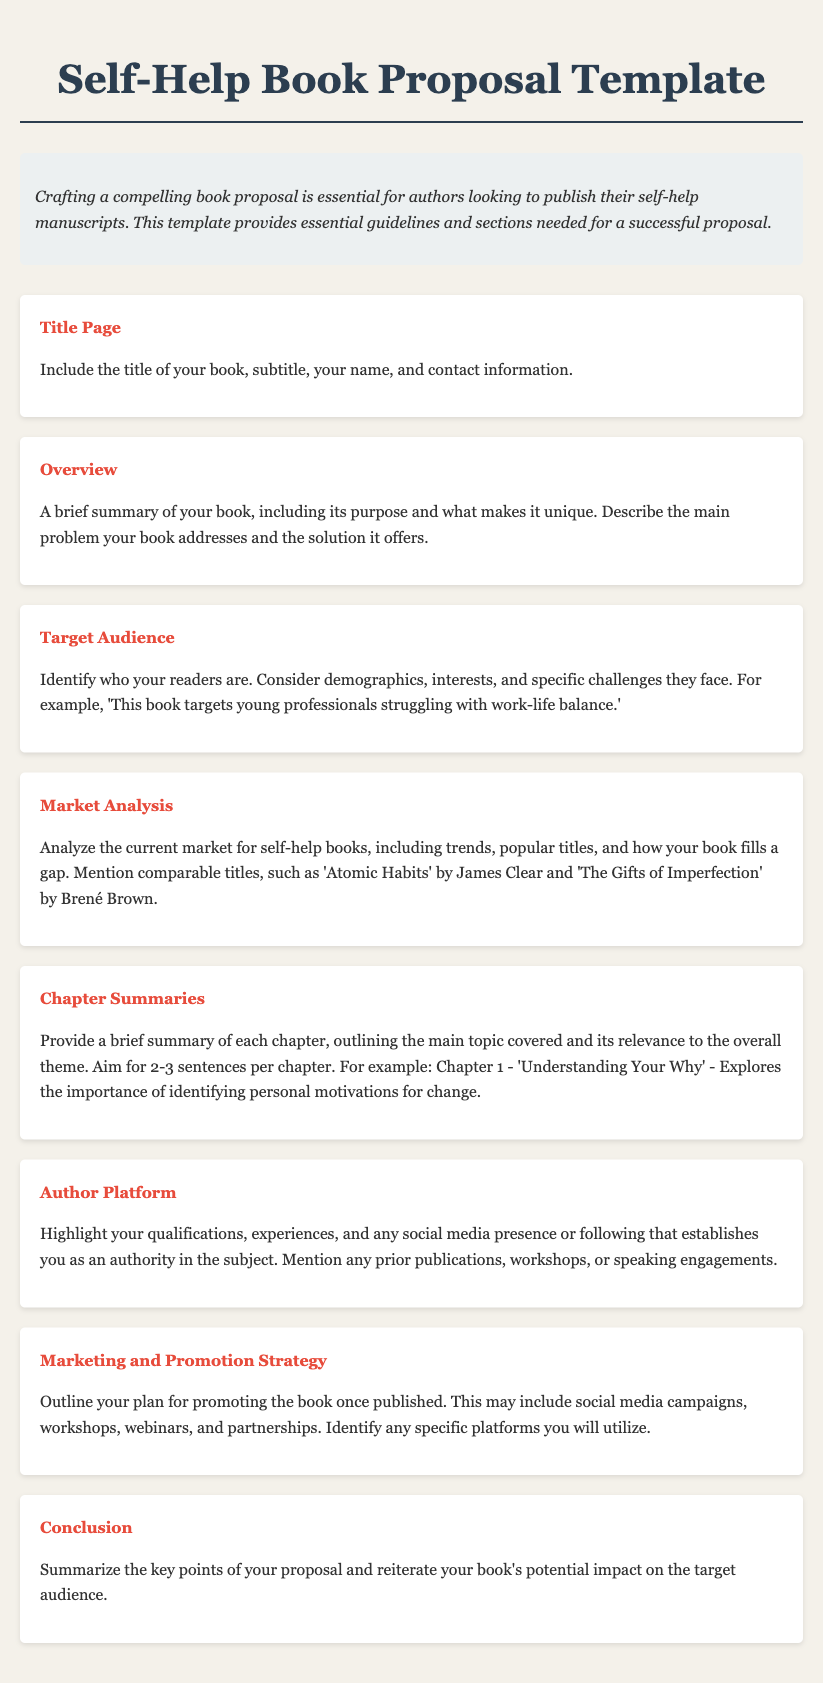What is the purpose of the book proposal template? The purpose of the book proposal template is to provide essential guidelines and sections needed for a successful proposal for self-help manuscripts.
Answer: Essential guidelines What is included in the Target Audience section? The Target Audience section includes identifying who the readers are, considering demographics, interests, and specific challenges they face.
Answer: Readers' demographics What should be analyzed in the Market Analysis section? The Market Analysis section should analyze the current market for self-help books, including trends, popular titles, and how the book fills a gap.
Answer: Current market trends How many sentences should be included in Chapter Summaries? The guidance suggests aiming for 2-3 sentences per chapter when providing chapter summaries.
Answer: 2-3 sentences What is emphasized in the Author Platform section? The Author Platform section highlights qualifications, experiences, and any social media presence or following establishing the author as an authority in the subject.
Answer: Qualifications and experiences What is the main focus of the Conclusion section? The Conclusion section summarizes the key points of the proposal and reiterates the book's potential impact on the target audience.
Answer: Key points summary What title is given to the first section of the proposal? The title of the first section is Title Page.
Answer: Title Page How does the template suggest promoting the book post-publication? The template outlines a plan for promoting the book, which may include social media campaigns, workshops, webinars, and partnerships.
Answer: Promotion plan What color is used for the section titles? The section titles are colored in red.
Answer: Red 